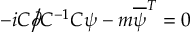<formula> <loc_0><loc_0><loc_500><loc_500>- i C { \partial \, { \Big / } } C ^ { - 1 } C \psi - m { \overline { \psi } } ^ { T } = 0</formula> 